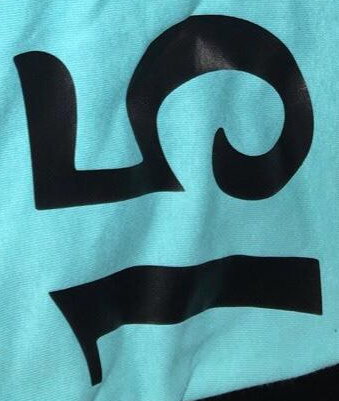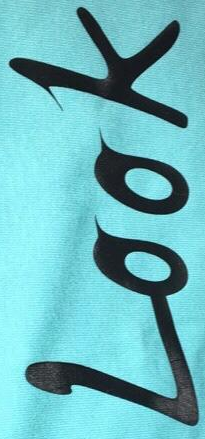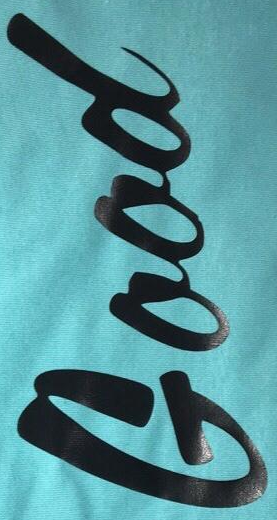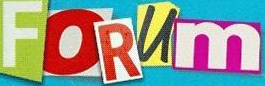What words can you see in these images in sequence, separated by a semicolon? 15; Look; Good; FORUm 